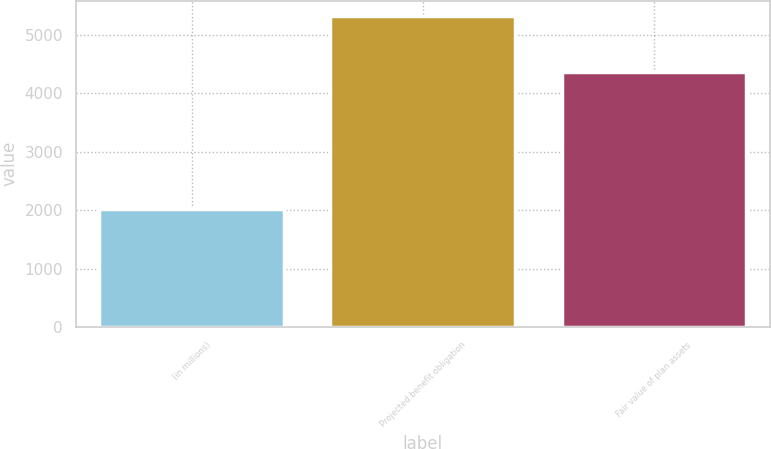<chart> <loc_0><loc_0><loc_500><loc_500><bar_chart><fcel>(in millions)<fcel>Projected benefit obligation<fcel>Fair value of plan assets<nl><fcel>2015<fcel>5324<fcel>4359<nl></chart> 